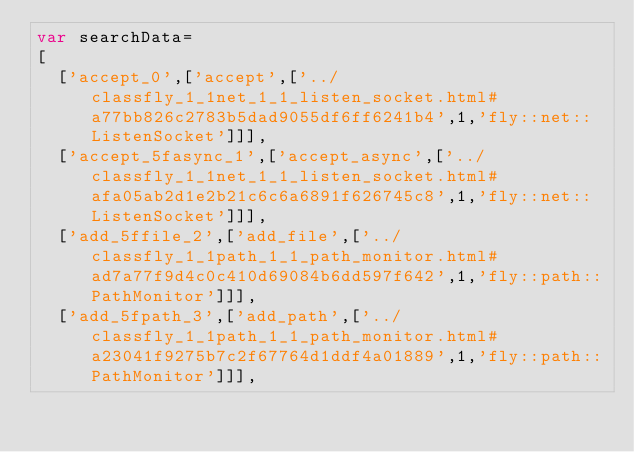<code> <loc_0><loc_0><loc_500><loc_500><_JavaScript_>var searchData=
[
  ['accept_0',['accept',['../classfly_1_1net_1_1_listen_socket.html#a77bb826c2783b5dad9055df6ff6241b4',1,'fly::net::ListenSocket']]],
  ['accept_5fasync_1',['accept_async',['../classfly_1_1net_1_1_listen_socket.html#afa05ab2d1e2b21c6c6a6891f626745c8',1,'fly::net::ListenSocket']]],
  ['add_5ffile_2',['add_file',['../classfly_1_1path_1_1_path_monitor.html#ad7a77f9d4c0c410d69084b6dd597f642',1,'fly::path::PathMonitor']]],
  ['add_5fpath_3',['add_path',['../classfly_1_1path_1_1_path_monitor.html#a23041f9275b7c2f67764d1ddf4a01889',1,'fly::path::PathMonitor']]],</code> 